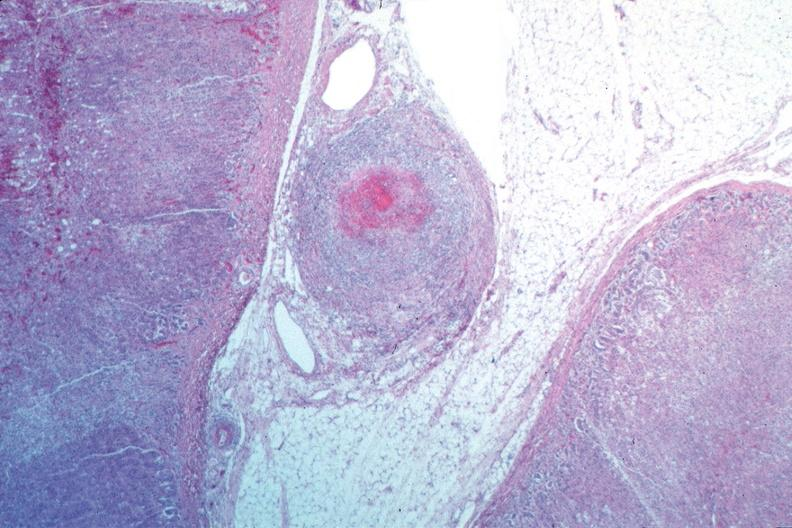s fat necrosis present?
Answer the question using a single word or phrase. No 